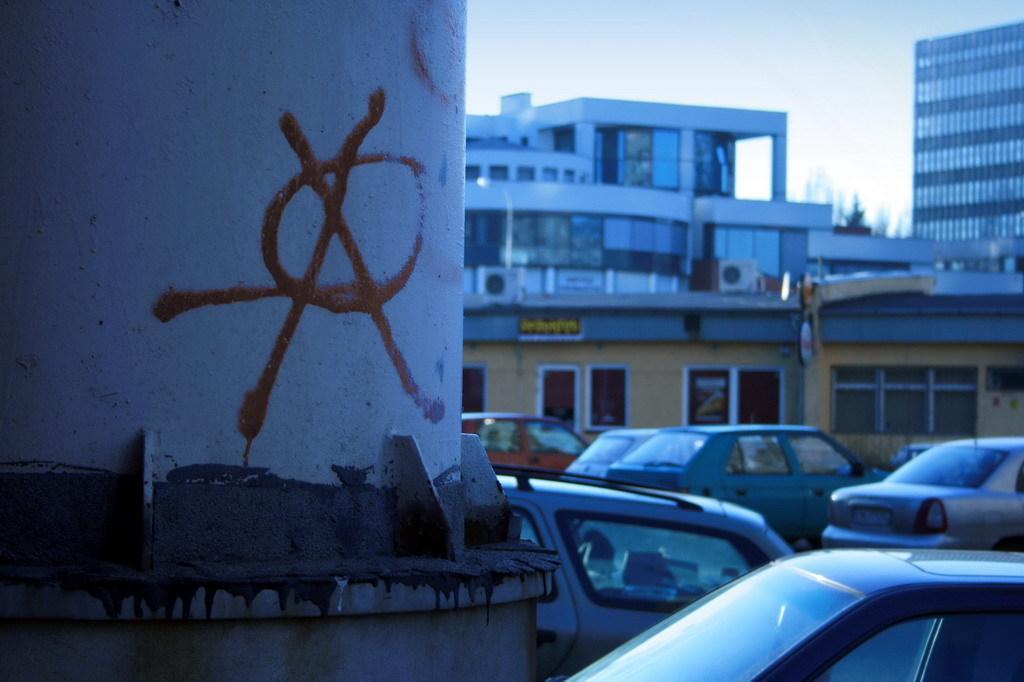In one or two sentences, can you explain what this image depicts? In this image we can see some buildings, some text on the building, two boards with text, some text on the pillar, some objects on the buildings, some vehicles on the ground, at the top there is the sky, one poster with text and image attached to the building. 